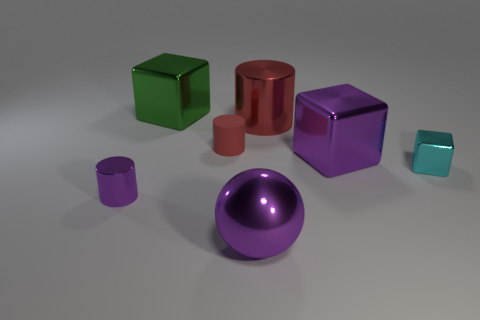Subtract all big metallic cubes. How many cubes are left? 1 Subtract all cyan blocks. How many red cylinders are left? 2 Subtract 3 cubes. How many cubes are left? 0 Add 3 small red matte cylinders. How many objects exist? 10 Subtract all red cylinders. How many cylinders are left? 1 Subtract all cylinders. How many objects are left? 4 Subtract all cyan cylinders. Subtract all gray blocks. How many cylinders are left? 3 Subtract all purple metallic objects. Subtract all big cyan shiny cubes. How many objects are left? 4 Add 2 green shiny objects. How many green shiny objects are left? 3 Add 5 large blue rubber cylinders. How many large blue rubber cylinders exist? 5 